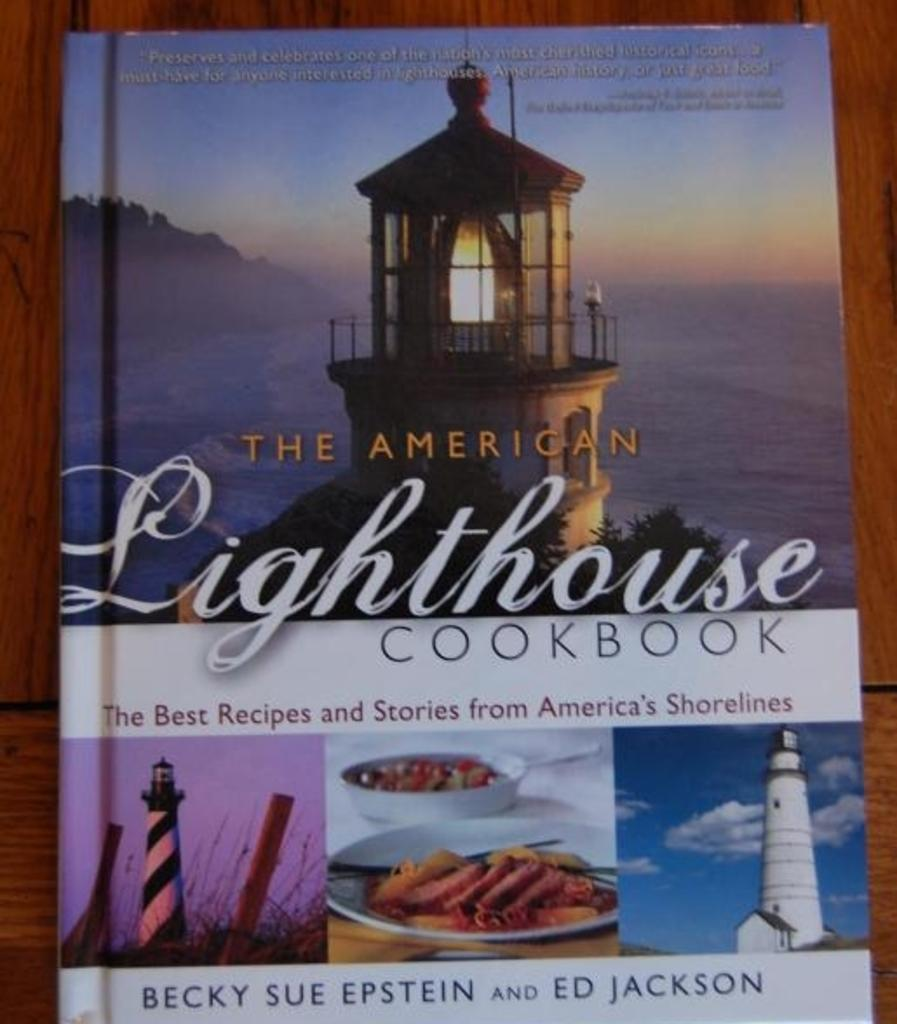<image>
Create a compact narrative representing the image presented. A cookbook that is by Authors named Becky and Ed. 